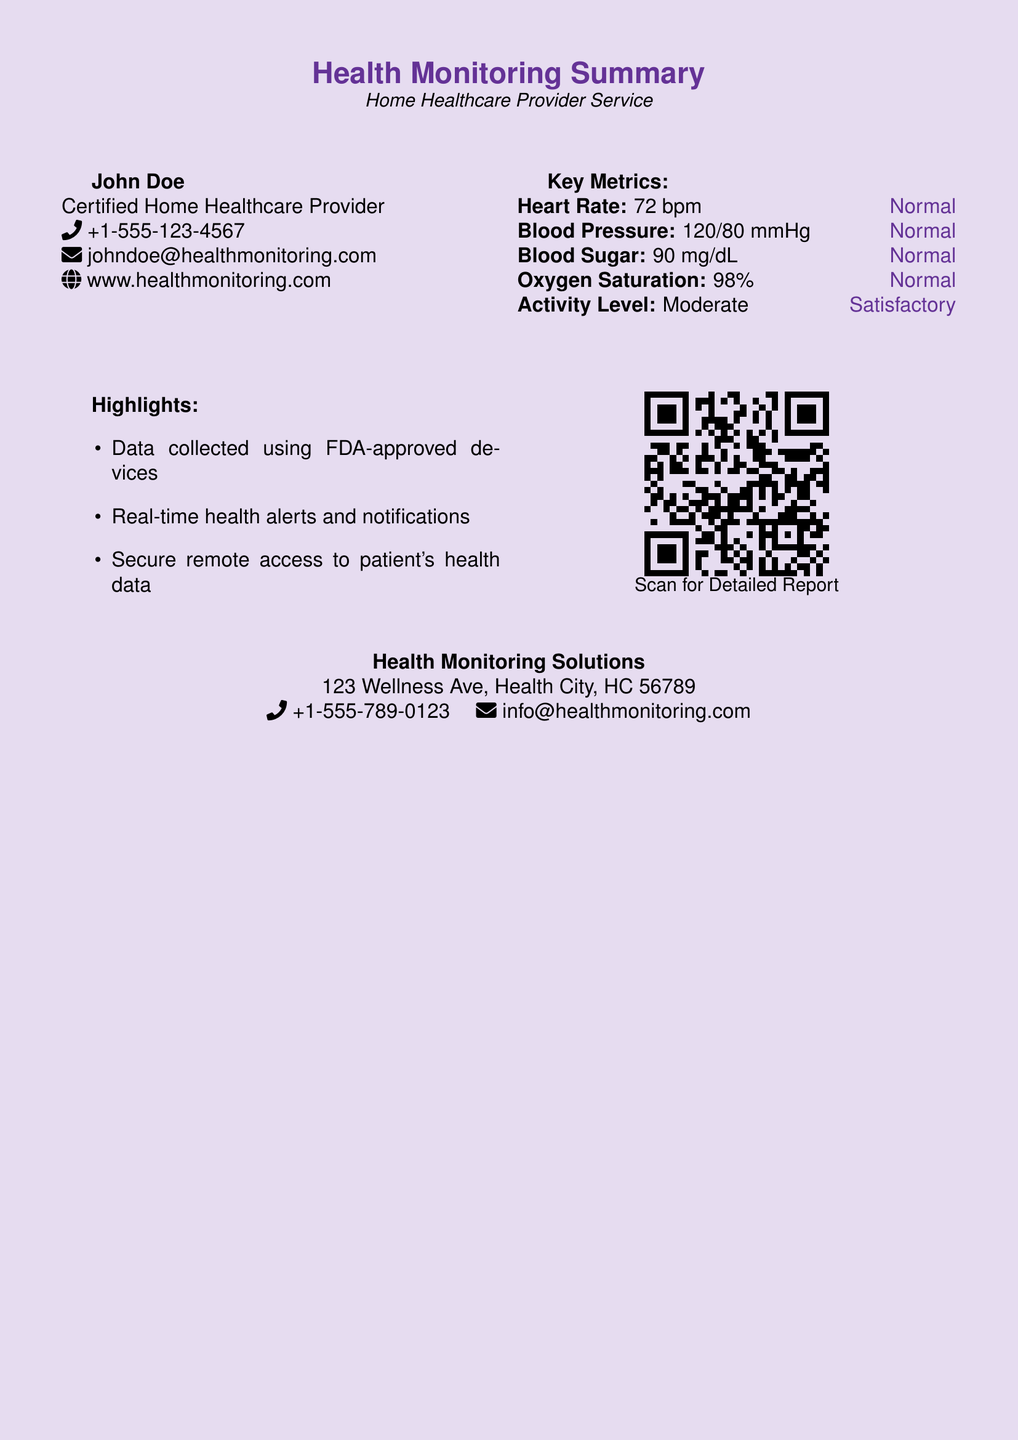what is the name of the healthcare provider? The name provided in the document is John Doe.
Answer: John Doe what is the heart rate listed? The document specifies the heart rate as 72 bpm.
Answer: 72 bpm what is the oxygen saturation level? The document states that the oxygen saturation level is 98%.
Answer: 98% what is the address of the health monitoring solutions? The address provided in the document is 123 Wellness Ave, Health City, HC 56789.
Answer: 123 Wellness Ave, Health City, HC 56789 how many key metrics are listed? The document lists five key metrics related to health monitoring.
Answer: Five what feature is mentioned for device validation? The document mentions that data is collected using FDA-approved devices.
Answer: FDA-approved devices what action can be taken by scanning the QR code? Scanning the QR code provides access to the detailed report.
Answer: Detailed Report what is the phone number of John Doe? The contact number provided for John Doe is +1-555-123-4567.
Answer: +1-555-123-4567 what type of alert does the health monitoring system provide? The document states that the system provides real-time health alerts.
Answer: Real-time health alerts 